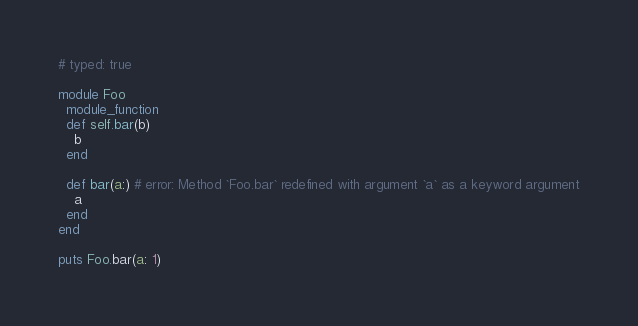Convert code to text. <code><loc_0><loc_0><loc_500><loc_500><_Ruby_># typed: true

module Foo
  module_function
  def self.bar(b)
    b
  end

  def bar(a:) # error: Method `Foo.bar` redefined with argument `a` as a keyword argument
    a
  end
end

puts Foo.bar(a: 1)
</code> 